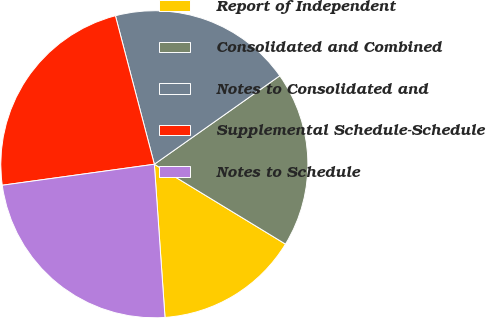Convert chart to OTSL. <chart><loc_0><loc_0><loc_500><loc_500><pie_chart><fcel>Report of Independent<fcel>Consolidated and Combined<fcel>Notes to Consolidated and<fcel>Supplemental Schedule-Schedule<fcel>Notes to Schedule<nl><fcel>15.19%<fcel>18.48%<fcel>19.3%<fcel>23.1%<fcel>23.92%<nl></chart> 